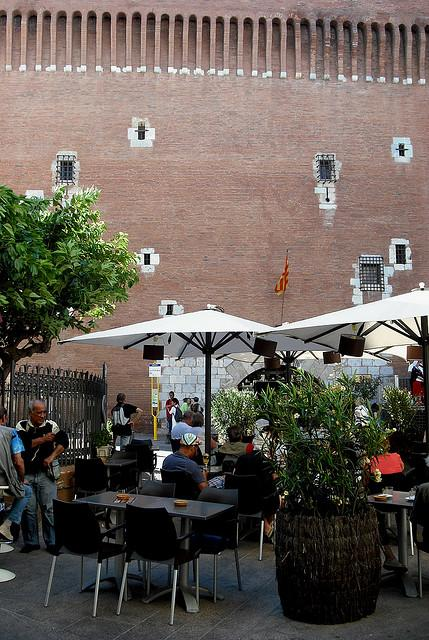Umbrellas provide what here?

Choices:
A) shade
B) color
C) advertising
D) rain cover shade 